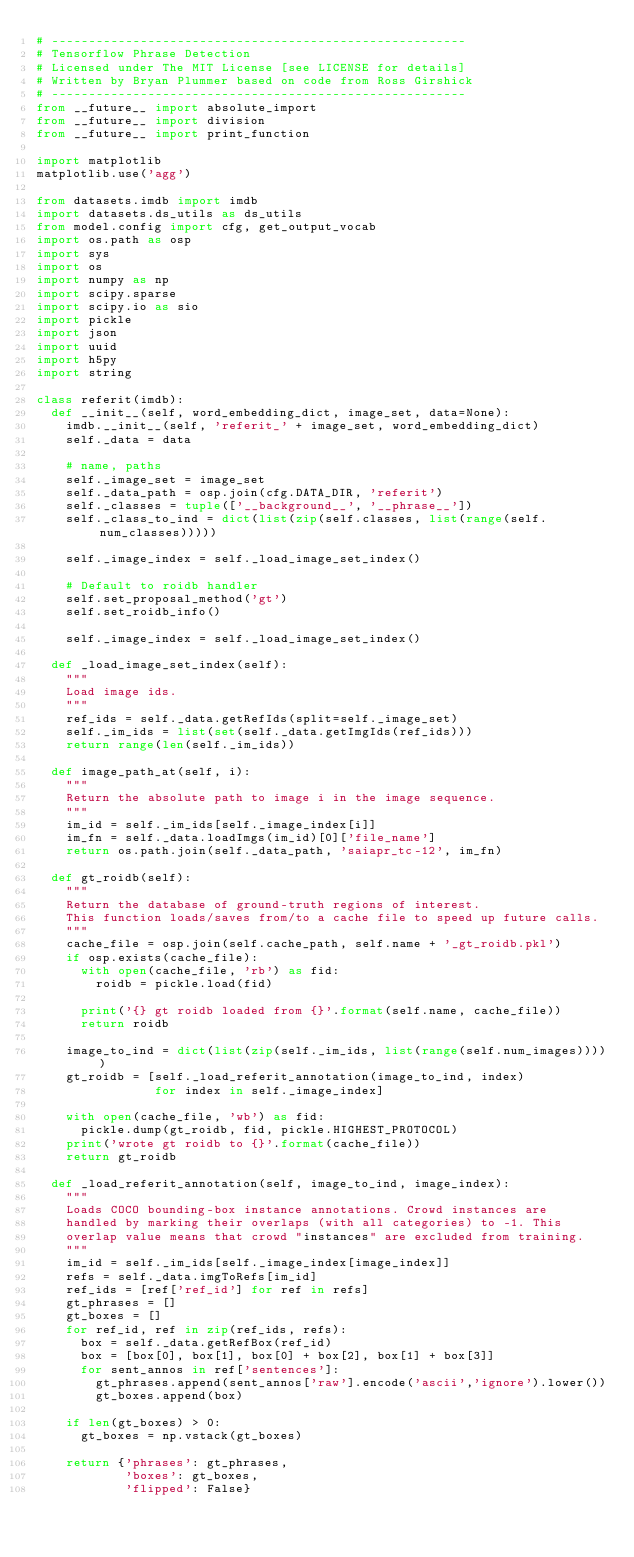<code> <loc_0><loc_0><loc_500><loc_500><_Python_># --------------------------------------------------------
# Tensorflow Phrase Detection
# Licensed under The MIT License [see LICENSE for details]
# Written by Bryan Plummer based on code from Ross Girshick
# --------------------------------------------------------
from __future__ import absolute_import
from __future__ import division
from __future__ import print_function

import matplotlib
matplotlib.use('agg')

from datasets.imdb import imdb
import datasets.ds_utils as ds_utils
from model.config import cfg, get_output_vocab
import os.path as osp
import sys
import os
import numpy as np
import scipy.sparse
import scipy.io as sio
import pickle
import json
import uuid
import h5py
import string

class referit(imdb):
  def __init__(self, word_embedding_dict, image_set, data=None):
    imdb.__init__(self, 'referit_' + image_set, word_embedding_dict)
    self._data = data

    # name, paths
    self._image_set = image_set
    self._data_path = osp.join(cfg.DATA_DIR, 'referit')
    self._classes = tuple(['__background__', '__phrase__'])
    self._class_to_ind = dict(list(zip(self.classes, list(range(self.num_classes)))))

    self._image_index = self._load_image_set_index()

    # Default to roidb handler
    self.set_proposal_method('gt')
    self.set_roidb_info()

    self._image_index = self._load_image_set_index()

  def _load_image_set_index(self):
    """
    Load image ids.
    """
    ref_ids = self._data.getRefIds(split=self._image_set)
    self._im_ids = list(set(self._data.getImgIds(ref_ids)))
    return range(len(self._im_ids))

  def image_path_at(self, i):
    """
    Return the absolute path to image i in the image sequence.
    """    
    im_id = self._im_ids[self._image_index[i]]
    im_fn = self._data.loadImgs(im_id)[0]['file_name']
    return os.path.join(self._data_path, 'saiapr_tc-12', im_fn)

  def gt_roidb(self):
    """
    Return the database of ground-truth regions of interest.
    This function loads/saves from/to a cache file to speed up future calls.
    """
    cache_file = osp.join(self.cache_path, self.name + '_gt_roidb.pkl')
    if osp.exists(cache_file):
      with open(cache_file, 'rb') as fid:
        roidb = pickle.load(fid)

      print('{} gt roidb loaded from {}'.format(self.name, cache_file))
      return roidb

    image_to_ind = dict(list(zip(self._im_ids, list(range(self.num_images)))))
    gt_roidb = [self._load_referit_annotation(image_to_ind, index)
                for index in self._image_index]

    with open(cache_file, 'wb') as fid:
      pickle.dump(gt_roidb, fid, pickle.HIGHEST_PROTOCOL)
    print('wrote gt roidb to {}'.format(cache_file))
    return gt_roidb

  def _load_referit_annotation(self, image_to_ind, image_index):
    """
    Loads COCO bounding-box instance annotations. Crowd instances are
    handled by marking their overlaps (with all categories) to -1. This
    overlap value means that crowd "instances" are excluded from training.
    """
    im_id = self._im_ids[self._image_index[image_index]]
    refs = self._data.imgToRefs[im_id]
    ref_ids = [ref['ref_id'] for ref in refs]
    gt_phrases = []
    gt_boxes = []
    for ref_id, ref in zip(ref_ids, refs):
      box = self._data.getRefBox(ref_id)
      box = [box[0], box[1], box[0] + box[2], box[1] + box[3]]
      for sent_annos in ref['sentences']:
        gt_phrases.append(sent_annos['raw'].encode('ascii','ignore').lower())
        gt_boxes.append(box)

    if len(gt_boxes) > 0:
      gt_boxes = np.vstack(gt_boxes)

    return {'phrases': gt_phrases,
            'boxes': gt_boxes,
            'flipped': False}

</code> 